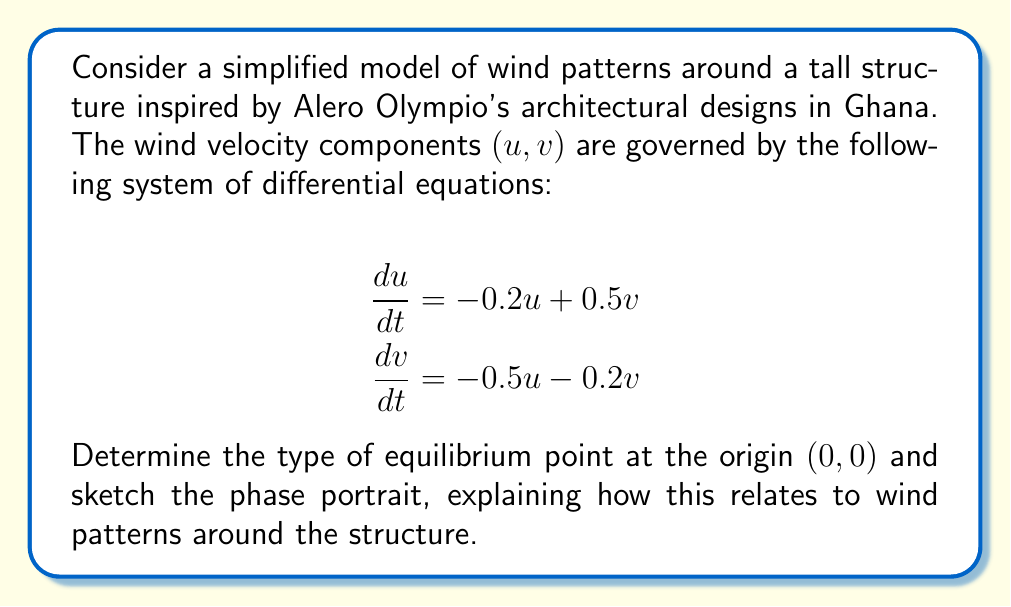Provide a solution to this math problem. 1) First, we need to find the Jacobian matrix of the system:

   $$J = \begin{bmatrix}
   \frac{\partial f_1}{\partial u} & \frac{\partial f_1}{\partial v} \\
   \frac{\partial f_2}{\partial u} & \frac{\partial f_2}{\partial v}
   \end{bmatrix} = \begin{bmatrix}
   -0.2 & 0.5 \\
   -0.5 & -0.2
   \end{bmatrix}$$

2) To determine the type of equilibrium point, we need to find the eigenvalues of J:

   $$\det(J - \lambda I) = \begin{vmatrix}
   -0.2 - \lambda & 0.5 \\
   -0.5 & -0.2 - \lambda
   \end{vmatrix} = 0$$

   $$\lambda^2 + 0.4\lambda + 0.29 = 0$$

3) Solving this quadratic equation:

   $$\lambda = \frac{-0.4 \pm \sqrt{0.16 - 1.16}}{2} = -0.2 \pm 0.5i$$

4) Since the eigenvalues are complex conjugates with negative real parts, the equilibrium point at (0,0) is a stable focus.

5) To sketch the phase portrait:

   [asy]
   import graph;
   size(200);
   
   void vector(pair z, pair v) {
     draw(z--z+v, arrow=Arrow(TeXHead));
   }
   
   for(int i=-4; i<=4; ++i) {
     for(int j=-4; j<=4; ++j) {
       real x = i/2;
       real y = j/2;
       pair z = (x,y);
       pair v = (-0.2*x+0.5*y, -0.5*x-0.2*y);
       vector(z, 0.3*v);
     }
   }
   
   draw(unitcircle, dashed);
   dot((0,0));
   label("(0,0)", (0,0), SW);
   [/asy]

6) The phase portrait shows spiraling trajectories converging to the origin, indicating that wind patterns around the structure will tend to stabilize over time.

7) This relates to wind patterns around tall structures as follows:
   - The origin (0,0) represents still air around the building.
   - Trajectories spiraling inwards indicate that wind disturbances will eventually die down.
   - The rate of convergence suggests how quickly the wind will stabilize after perturbations.
   - The circular nature of the spirals indicates a swirling pattern in the wind as it stabilizes.

This analysis can help in understanding how wind will behave around Alero Olympio-inspired tall structures in Ghana, aiding in design decisions for wind resistance and comfort in surrounding areas.
Answer: Stable focus; wind patterns spiral inwards, stabilizing over time. 